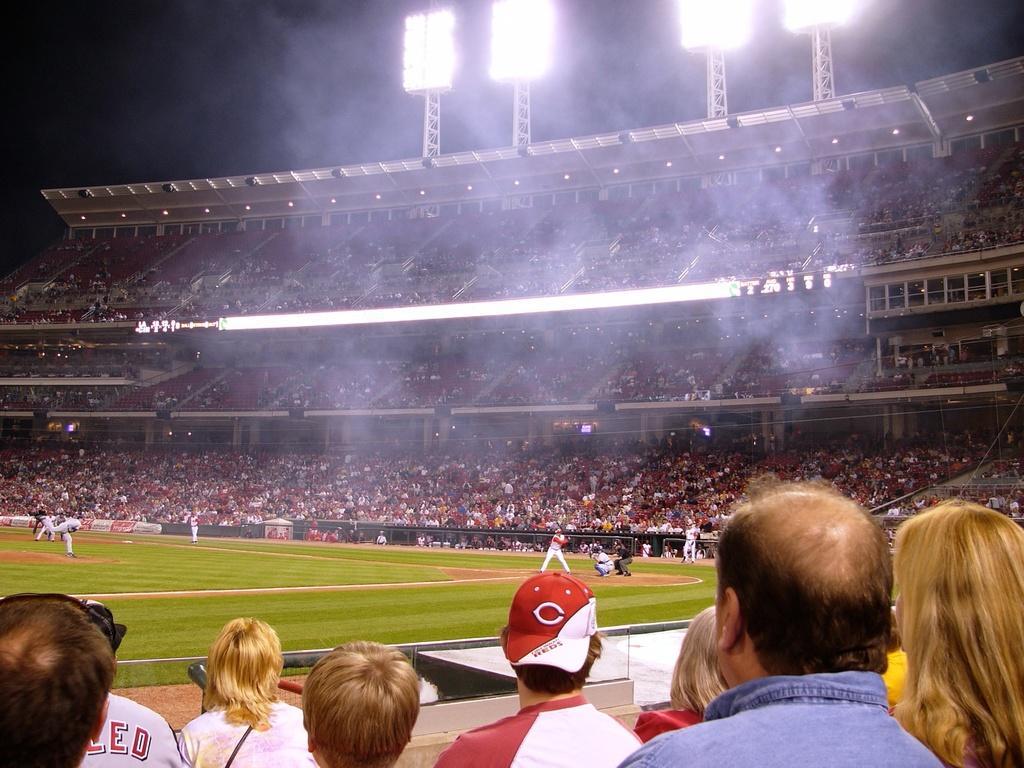How would you summarize this image in a sentence or two? In this picture I can see a stadium. I can see group of people, lights, lighting trusses and some other objects, and there is dark background. 